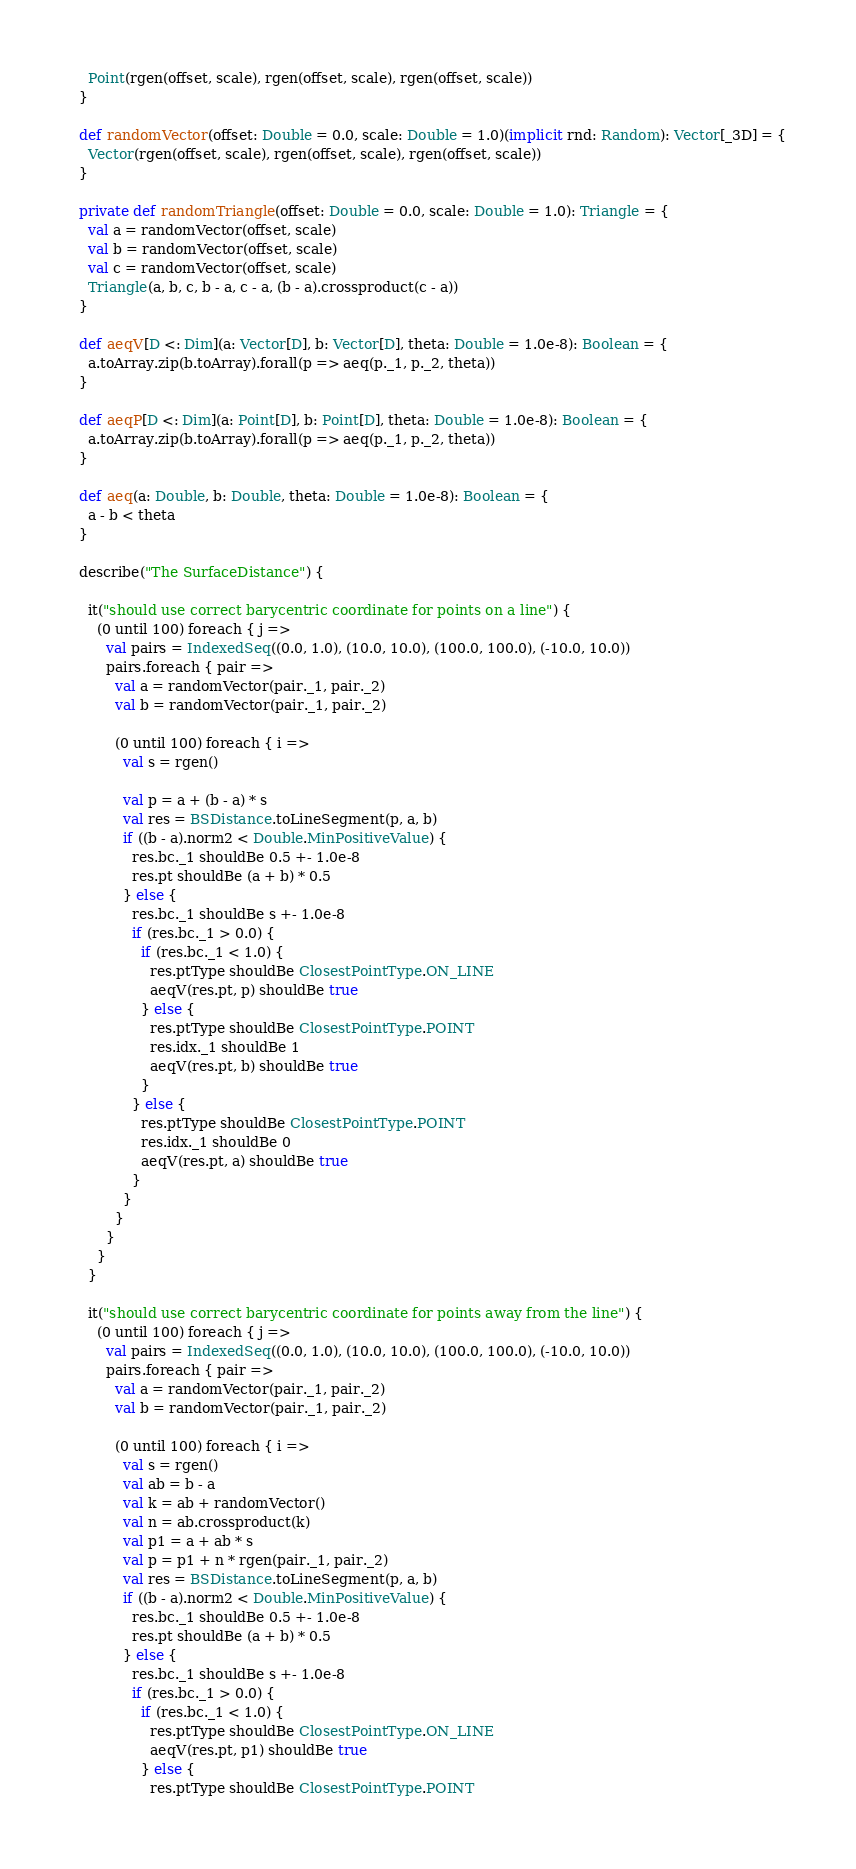<code> <loc_0><loc_0><loc_500><loc_500><_Scala_>    Point(rgen(offset, scale), rgen(offset, scale), rgen(offset, scale))
  }

  def randomVector(offset: Double = 0.0, scale: Double = 1.0)(implicit rnd: Random): Vector[_3D] = {
    Vector(rgen(offset, scale), rgen(offset, scale), rgen(offset, scale))
  }

  private def randomTriangle(offset: Double = 0.0, scale: Double = 1.0): Triangle = {
    val a = randomVector(offset, scale)
    val b = randomVector(offset, scale)
    val c = randomVector(offset, scale)
    Triangle(a, b, c, b - a, c - a, (b - a).crossproduct(c - a))
  }

  def aeqV[D <: Dim](a: Vector[D], b: Vector[D], theta: Double = 1.0e-8): Boolean = {
    a.toArray.zip(b.toArray).forall(p => aeq(p._1, p._2, theta))
  }

  def aeqP[D <: Dim](a: Point[D], b: Point[D], theta: Double = 1.0e-8): Boolean = {
    a.toArray.zip(b.toArray).forall(p => aeq(p._1, p._2, theta))
  }

  def aeq(a: Double, b: Double, theta: Double = 1.0e-8): Boolean = {
    a - b < theta
  }

  describe("The SurfaceDistance") {

    it("should use correct barycentric coordinate for points on a line") {
      (0 until 100) foreach { j =>
        val pairs = IndexedSeq((0.0, 1.0), (10.0, 10.0), (100.0, 100.0), (-10.0, 10.0))
        pairs.foreach { pair =>
          val a = randomVector(pair._1, pair._2)
          val b = randomVector(pair._1, pair._2)

          (0 until 100) foreach { i =>
            val s = rgen()

            val p = a + (b - a) * s
            val res = BSDistance.toLineSegment(p, a, b)
            if ((b - a).norm2 < Double.MinPositiveValue) {
              res.bc._1 shouldBe 0.5 +- 1.0e-8
              res.pt shouldBe (a + b) * 0.5
            } else {
              res.bc._1 shouldBe s +- 1.0e-8
              if (res.bc._1 > 0.0) {
                if (res.bc._1 < 1.0) {
                  res.ptType shouldBe ClosestPointType.ON_LINE
                  aeqV(res.pt, p) shouldBe true
                } else {
                  res.ptType shouldBe ClosestPointType.POINT
                  res.idx._1 shouldBe 1
                  aeqV(res.pt, b) shouldBe true
                }
              } else {
                res.ptType shouldBe ClosestPointType.POINT
                res.idx._1 shouldBe 0
                aeqV(res.pt, a) shouldBe true
              }
            }
          }
        }
      }
    }

    it("should use correct barycentric coordinate for points away from the line") {
      (0 until 100) foreach { j =>
        val pairs = IndexedSeq((0.0, 1.0), (10.0, 10.0), (100.0, 100.0), (-10.0, 10.0))
        pairs.foreach { pair =>
          val a = randomVector(pair._1, pair._2)
          val b = randomVector(pair._1, pair._2)

          (0 until 100) foreach { i =>
            val s = rgen()
            val ab = b - a
            val k = ab + randomVector()
            val n = ab.crossproduct(k)
            val p1 = a + ab * s
            val p = p1 + n * rgen(pair._1, pair._2)
            val res = BSDistance.toLineSegment(p, a, b)
            if ((b - a).norm2 < Double.MinPositiveValue) {
              res.bc._1 shouldBe 0.5 +- 1.0e-8
              res.pt shouldBe (a + b) * 0.5
            } else {
              res.bc._1 shouldBe s +- 1.0e-8
              if (res.bc._1 > 0.0) {
                if (res.bc._1 < 1.0) {
                  res.ptType shouldBe ClosestPointType.ON_LINE
                  aeqV(res.pt, p1) shouldBe true
                } else {
                  res.ptType shouldBe ClosestPointType.POINT</code> 